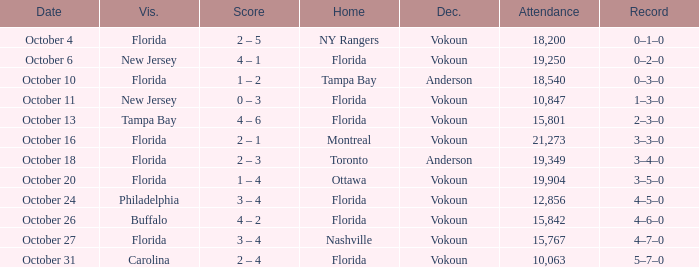What was the score on October 31? 2 – 4. 